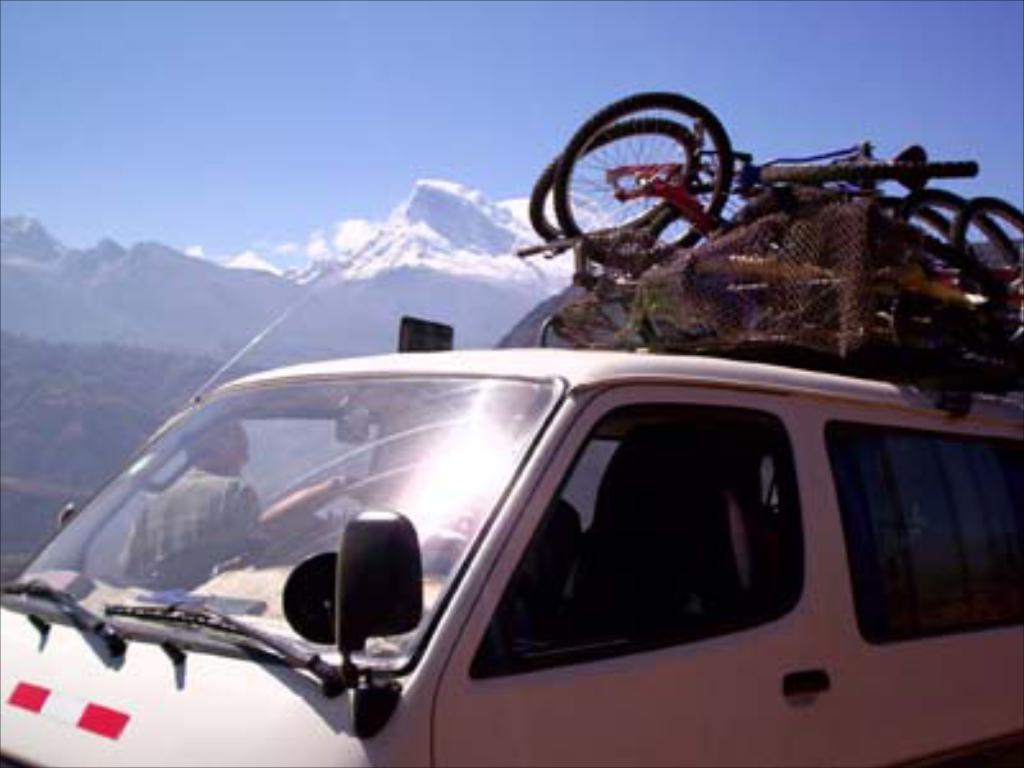What is the main subject of the image? There is a vehicle in the image. What is on top of the vehicle? There are bicycles on top of the vehicle. What can be seen in the background of the image? Mountains and the sky are visible in the background of the image. Where can the mice be found playing in the image? There are no mice present in the image. What type of amusement park can be seen in the background of the image? There is no amusement park visible in the image; only mountains and the sky are present in the background. 